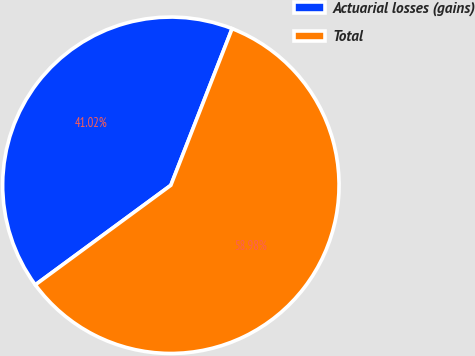<chart> <loc_0><loc_0><loc_500><loc_500><pie_chart><fcel>Actuarial losses (gains)<fcel>Total<nl><fcel>41.02%<fcel>58.98%<nl></chart> 